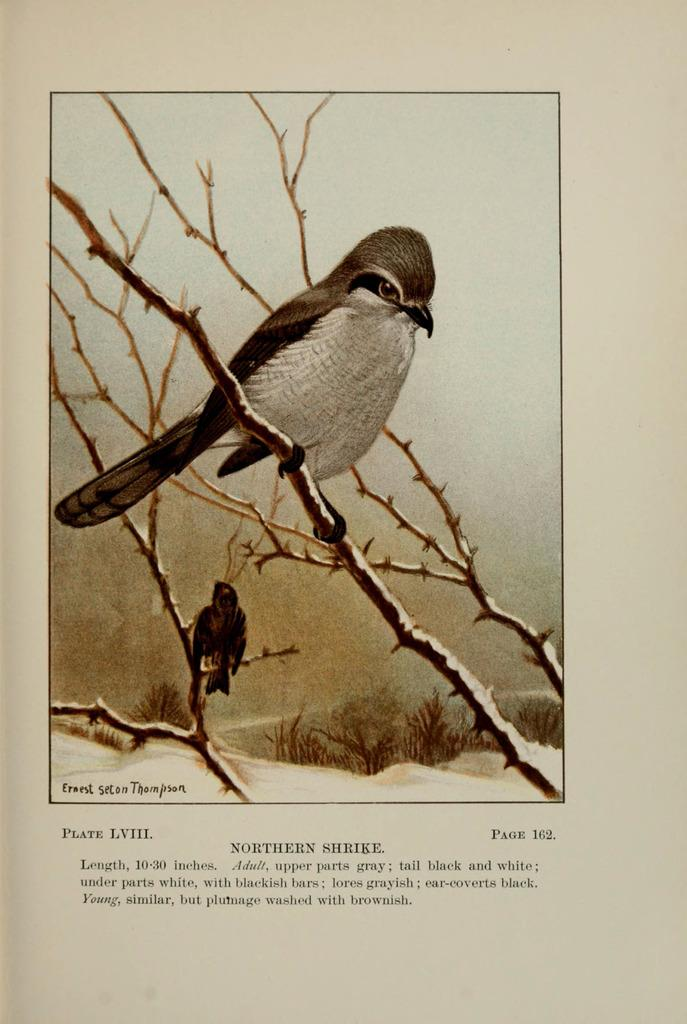What is depicted in the painting in the image? There is a painting of a bird in the image. Can you describe the scene involving birds in the image? There are two birds on a tree in the image. What type of vegetation is present at the bottom of the image? There are plants at the bottom of the image. What is written or displayed at the bottom of the image? There is text at the bottom of the image. What type of dinner is being served to the pigs in the image? There are no pigs or dinner present in the image. Can you describe the hand holding the painting in the image? There is no hand holding the painting in the image; it is a flat image of a painting. 